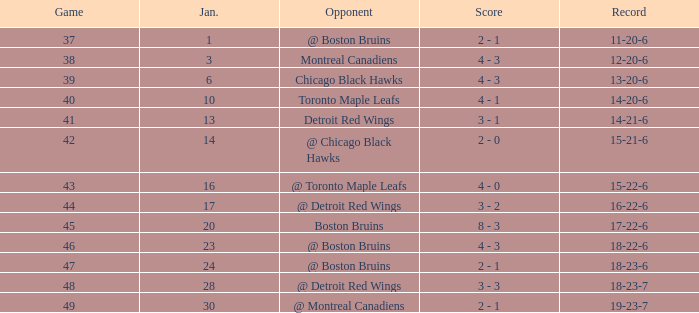Parse the table in full. {'header': ['Game', 'Jan.', 'Opponent', 'Score', 'Record'], 'rows': [['37', '1', '@ Boston Bruins', '2 - 1', '11-20-6'], ['38', '3', 'Montreal Canadiens', '4 - 3', '12-20-6'], ['39', '6', 'Chicago Black Hawks', '4 - 3', '13-20-6'], ['40', '10', 'Toronto Maple Leafs', '4 - 1', '14-20-6'], ['41', '13', 'Detroit Red Wings', '3 - 1', '14-21-6'], ['42', '14', '@ Chicago Black Hawks', '2 - 0', '15-21-6'], ['43', '16', '@ Toronto Maple Leafs', '4 - 0', '15-22-6'], ['44', '17', '@ Detroit Red Wings', '3 - 2', '16-22-6'], ['45', '20', 'Boston Bruins', '8 - 3', '17-22-6'], ['46', '23', '@ Boston Bruins', '4 - 3', '18-22-6'], ['47', '24', '@ Boston Bruins', '2 - 1', '18-23-6'], ['48', '28', '@ Detroit Red Wings', '3 - 3', '18-23-7'], ['49', '30', '@ Montreal Canadiens', '2 - 1', '19-23-7']]} Who was the opponent with the record of 15-21-6? @ Chicago Black Hawks. 